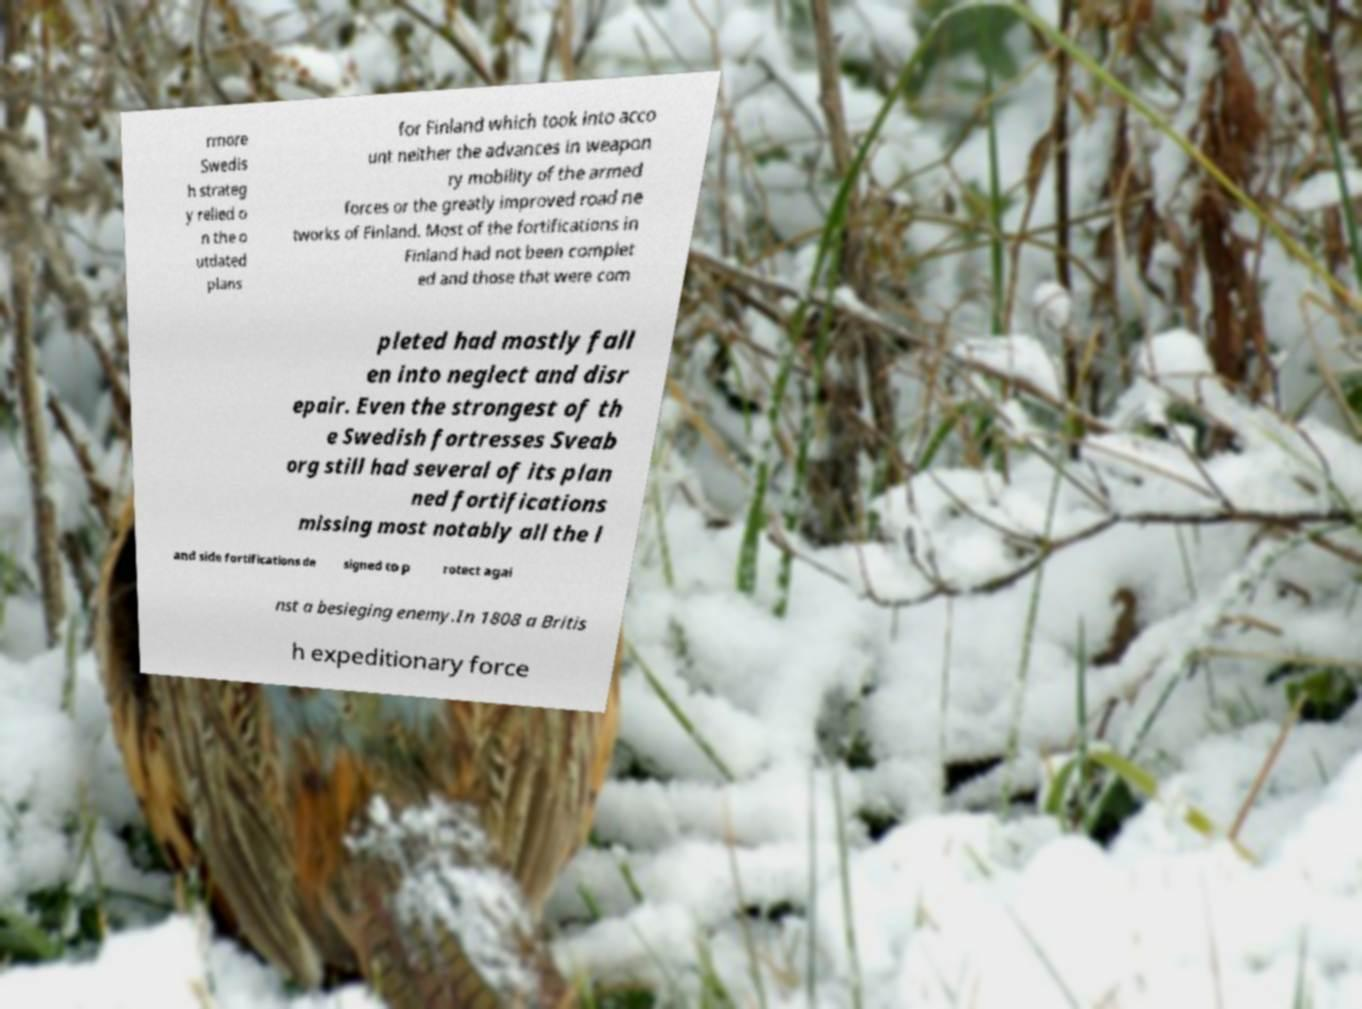Can you read and provide the text displayed in the image?This photo seems to have some interesting text. Can you extract and type it out for me? rmore Swedis h strateg y relied o n the o utdated plans for Finland which took into acco unt neither the advances in weapon ry mobility of the armed forces or the greatly improved road ne tworks of Finland. Most of the fortifications in Finland had not been complet ed and those that were com pleted had mostly fall en into neglect and disr epair. Even the strongest of th e Swedish fortresses Sveab org still had several of its plan ned fortifications missing most notably all the l and side fortifications de signed to p rotect agai nst a besieging enemy.In 1808 a Britis h expeditionary force 